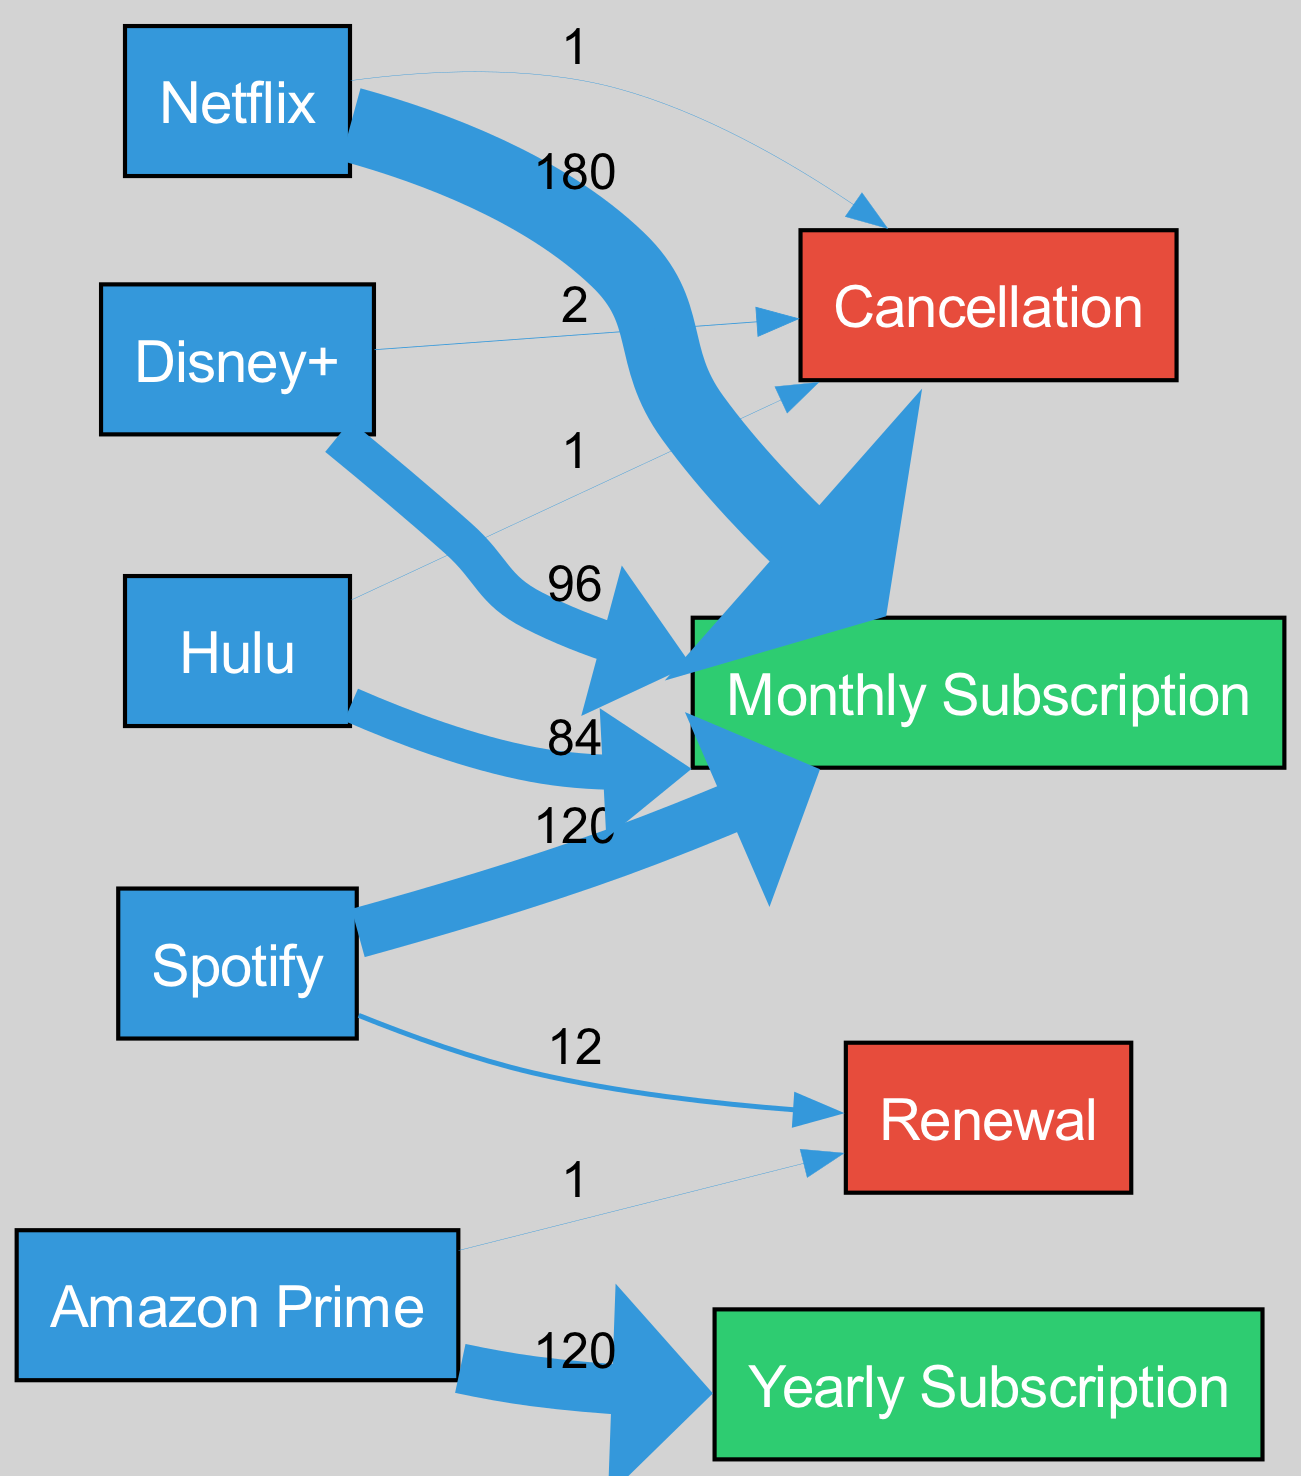What is the total expenditure on Netflix in a year? The expenditure on Netflix is represented as a flow to the "Monthly Subscription" node, showing a value of 180. This figure indicates the total amount spent on Netflix throughout the year.
Answer: 180 How many cancellations occurred for Amazon Prime? The diagram shows a flow from Amazon Prime to the "Cancellation" node with a value of 1. This indicates that there was one cancellation for this service in the year.
Answer: 1 Which service had the highest monthly subscription expenditure? By comparing the flows to the "Monthly Subscription" node, Netflix has the largest flow with a value of 180, while the other services have lower values. Therefore, it had the highest expenditure.
Answer: Netflix What is the total value of renewals for all services? Adding the values of the flows to the "Renewal" node, we have 12 for Spotify and 1 for Amazon Prime, totaling 13 across all services. The total value is derived by summing these flows.
Answer: 13 Which service had the most cancellations? The flows leading to the "Cancellation" node indicate that Disney+ had a value of 2, while the others had values of 1. Therefore, Disney+ experiences the most cancellations.
Answer: Disney+ What is the combined monthly subscription expenditure for all services? By summing the values for all services that flow to the "Monthly Subscription" node: 180 (Netflix) + 120 (Spotify) + 96 (Disney+) + 84 (Hulu) = 480. This provides the total monthly expenditure for the listed services.
Answer: 480 How many total unique services are represented in the diagram? The diagram lists five unique services (Netflix, Spotify, Amazon Prime, Disney+, and Hulu). Counting these services reflects the total number of distinct nodes labeled as services.
Answer: 5 Which service had a flow to both Cancellation and Renewal? The data shows that Spotify has a renewal flow of 12 and no cancellation flow; Amazon Prime has a renewal of 1 and no cancellation; however, none of the services list both events. Thus, none have flows to both nodes.
Answer: None 